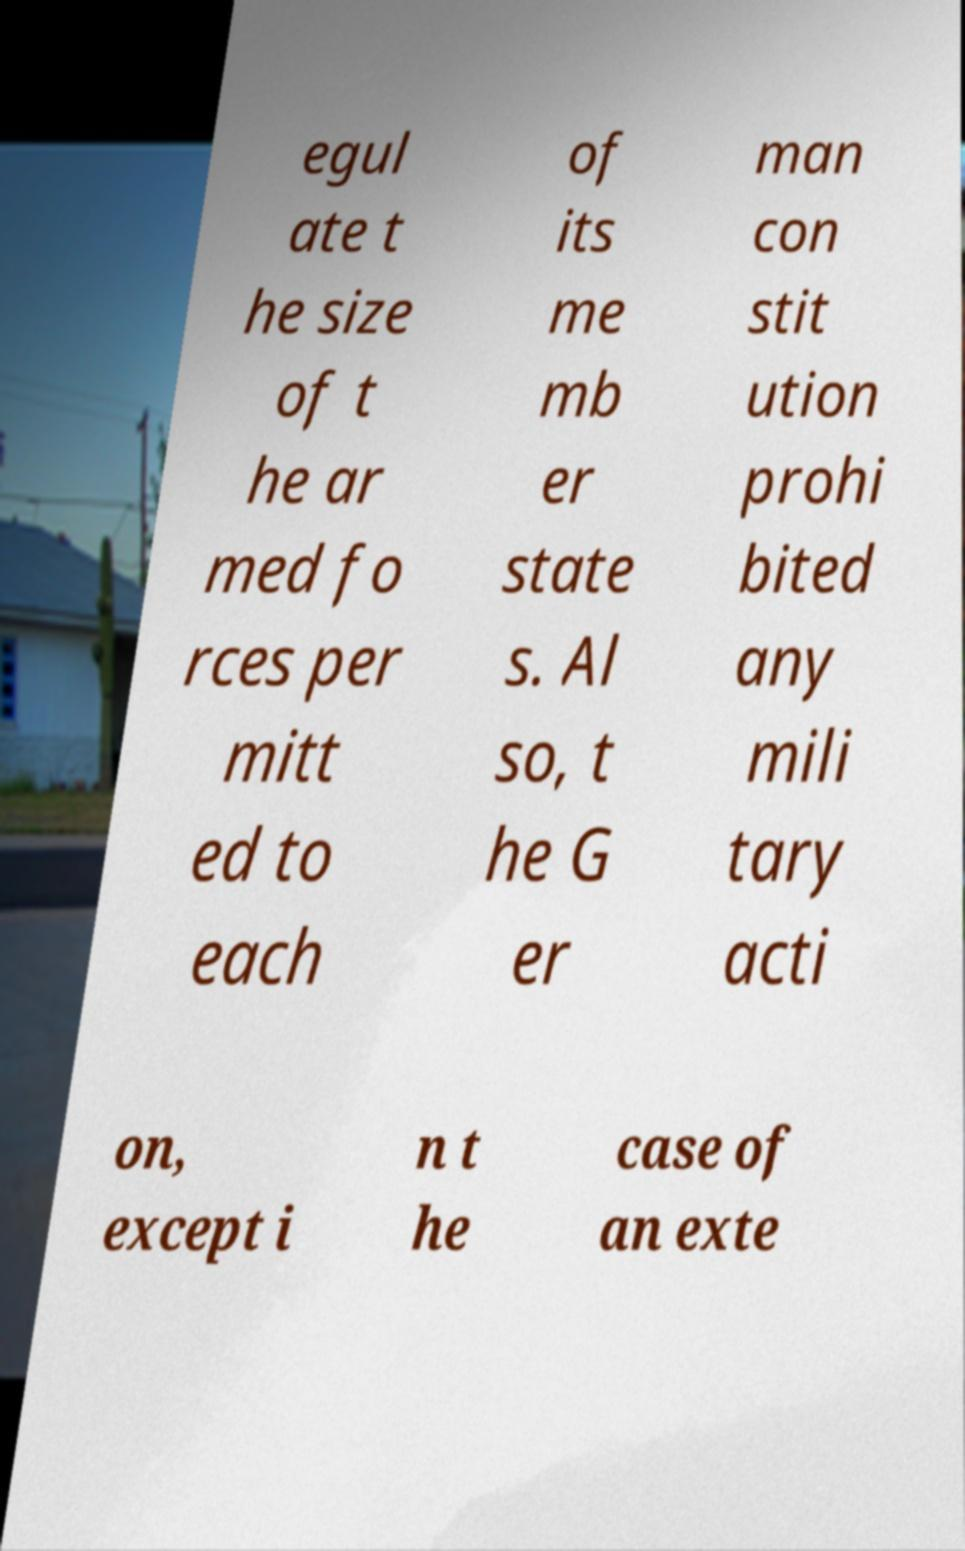Please identify and transcribe the text found in this image. egul ate t he size of t he ar med fo rces per mitt ed to each of its me mb er state s. Al so, t he G er man con stit ution prohi bited any mili tary acti on, except i n t he case of an exte 